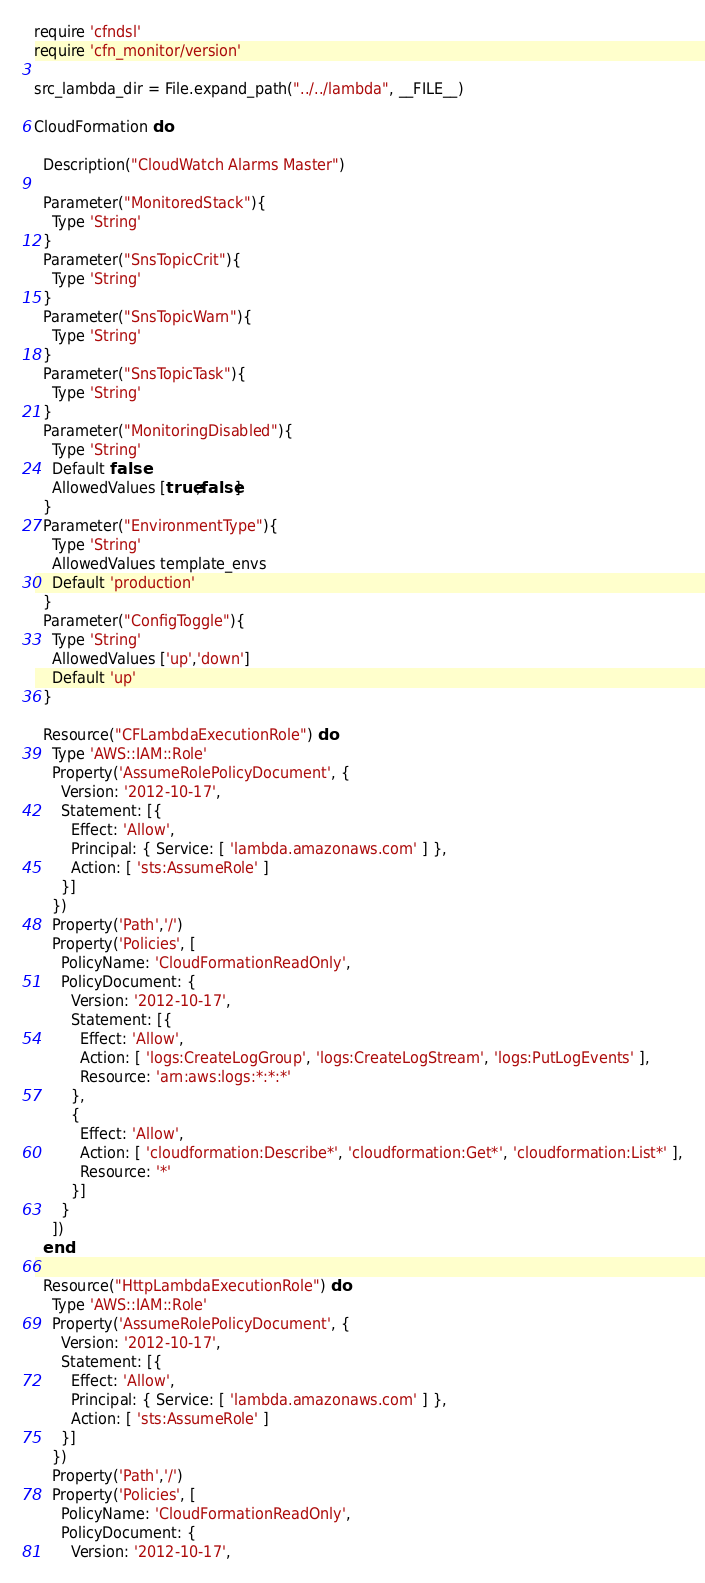Convert code to text. <code><loc_0><loc_0><loc_500><loc_500><_Ruby_>require 'cfndsl'
require 'cfn_monitor/version'

src_lambda_dir = File.expand_path("../../lambda", __FILE__)

CloudFormation do

  Description("CloudWatch Alarms Master")

  Parameter("MonitoredStack"){
    Type 'String'
  }
  Parameter("SnsTopicCrit"){
    Type 'String'
  }
  Parameter("SnsTopicWarn"){
    Type 'String'
  }
  Parameter("SnsTopicTask"){
    Type 'String'
  }
  Parameter("MonitoringDisabled"){
    Type 'String'
    Default false
    AllowedValues [true,false]
  }
  Parameter("EnvironmentType"){
    Type 'String'
    AllowedValues template_envs
    Default 'production'
  }
  Parameter("ConfigToggle"){
    Type 'String'
    AllowedValues ['up','down']
    Default 'up'
  }

  Resource("CFLambdaExecutionRole") do
    Type 'AWS::IAM::Role'
    Property('AssumeRolePolicyDocument', {
      Version: '2012-10-17',
      Statement: [{
        Effect: 'Allow',
        Principal: { Service: [ 'lambda.amazonaws.com' ] },
        Action: [ 'sts:AssumeRole' ]
      }]
    })
    Property('Path','/')
    Property('Policies', [
      PolicyName: 'CloudFormationReadOnly',
      PolicyDocument: {
        Version: '2012-10-17',
        Statement: [{
          Effect: 'Allow',
          Action: [ 'logs:CreateLogGroup', 'logs:CreateLogStream', 'logs:PutLogEvents' ],
          Resource: 'arn:aws:logs:*:*:*'
        },
        {
          Effect: 'Allow',
          Action: [ 'cloudformation:Describe*', 'cloudformation:Get*', 'cloudformation:List*' ],
          Resource: '*'
        }]
      }
    ])
  end

  Resource("HttpLambdaExecutionRole") do
    Type 'AWS::IAM::Role'
    Property('AssumeRolePolicyDocument', {
      Version: '2012-10-17',
      Statement: [{
        Effect: 'Allow',
        Principal: { Service: [ 'lambda.amazonaws.com' ] },
        Action: [ 'sts:AssumeRole' ]
      }]
    })
    Property('Path','/')
    Property('Policies', [
      PolicyName: 'CloudFormationReadOnly',
      PolicyDocument: {
        Version: '2012-10-17',</code> 